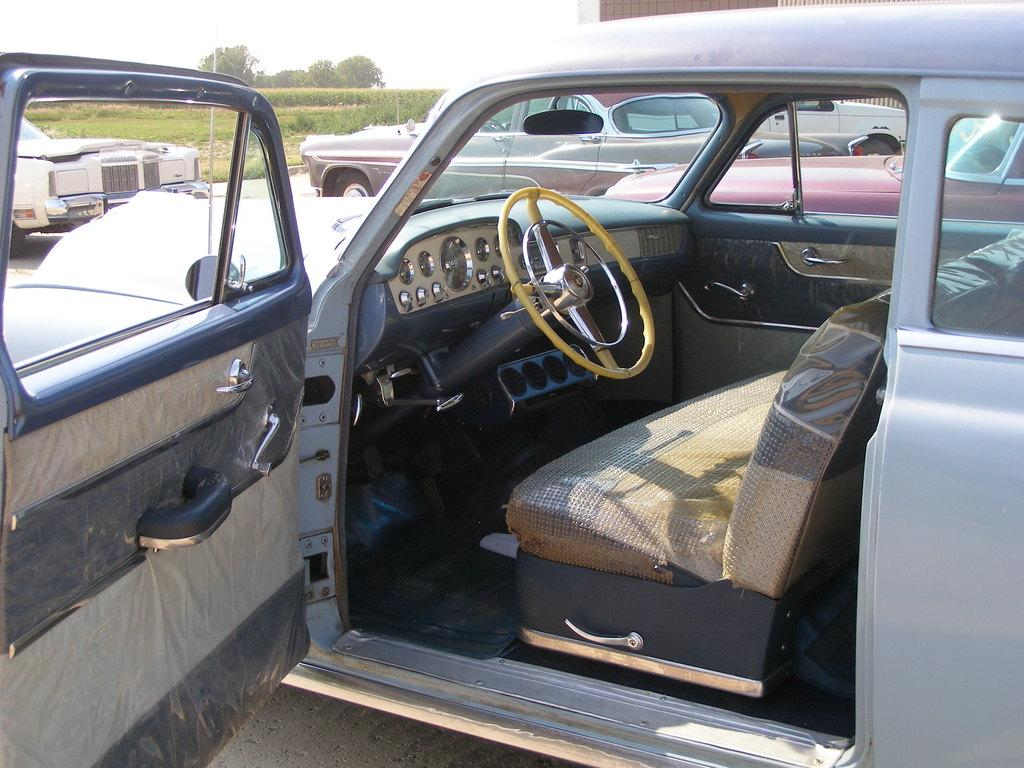What types of objects are present in the image? There are vehicles in the image. What type of natural environment is visible in the image? There is grass, plants, and trees in the image. What part of the natural environment is visible in the image? The sky is visible in the image. Can you tell me how many lawyers are smiling in the image? There are no lawyers or smiles present in the image. What type of farm can be seen in the image? There is no farm present in the image. 